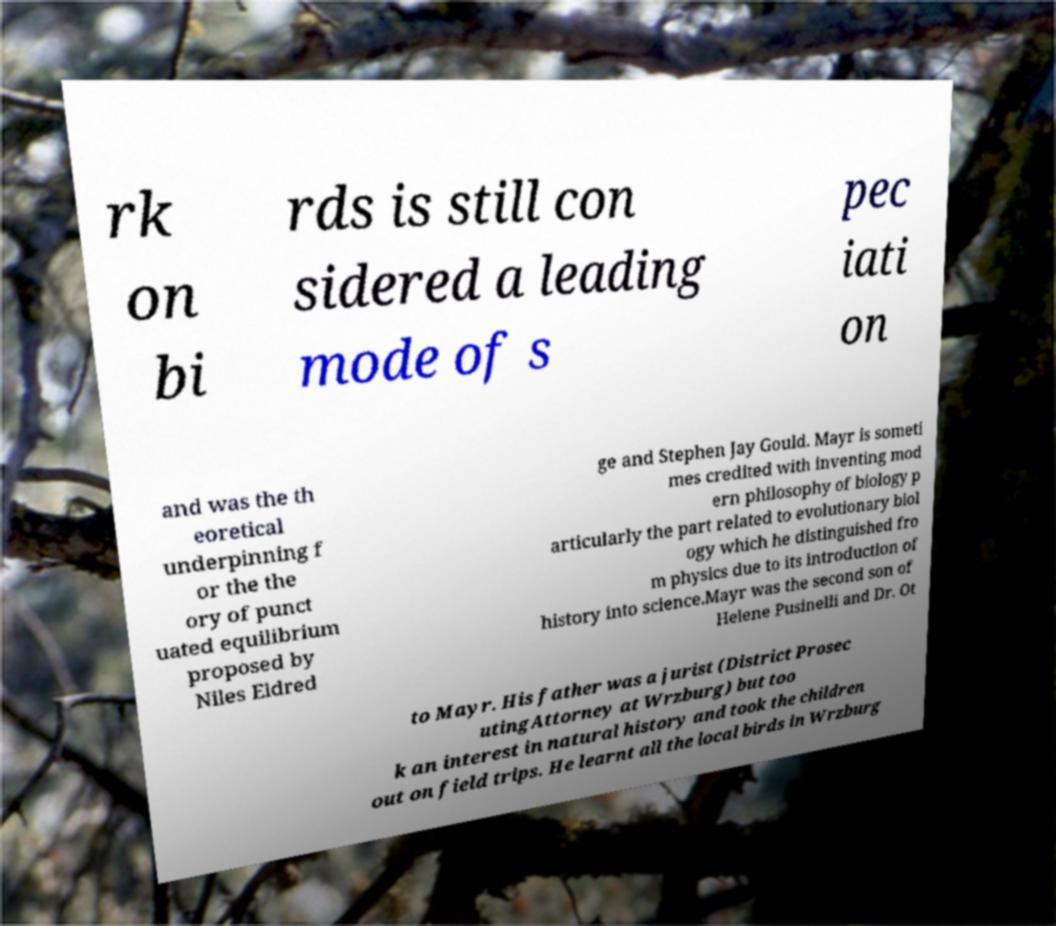Can you accurately transcribe the text from the provided image for me? rk on bi rds is still con sidered a leading mode of s pec iati on and was the th eoretical underpinning f or the the ory of punct uated equilibrium proposed by Niles Eldred ge and Stephen Jay Gould. Mayr is someti mes credited with inventing mod ern philosophy of biology p articularly the part related to evolutionary biol ogy which he distinguished fro m physics due to its introduction of history into science.Mayr was the second son of Helene Pusinelli and Dr. Ot to Mayr. His father was a jurist (District Prosec utingAttorney at Wrzburg) but too k an interest in natural history and took the children out on field trips. He learnt all the local birds in Wrzburg 